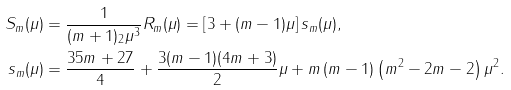<formula> <loc_0><loc_0><loc_500><loc_500>S _ { m } ( \mu ) & = \frac { 1 } { ( m + 1 ) _ { 2 } \mu ^ { 3 } } R _ { m } ( \mu ) = \left [ 3 + ( m - 1 ) \mu \right ] s _ { m } ( \mu ) , \\ s _ { m } ( \mu ) & = \frac { 3 5 m + 2 7 } { 4 } + \frac { 3 ( m - 1 ) ( 4 m + 3 ) } { 2 } \mu + m \left ( m - 1 \right ) \left ( m ^ { 2 } - 2 m - 2 \right ) \mu ^ { 2 } .</formula> 